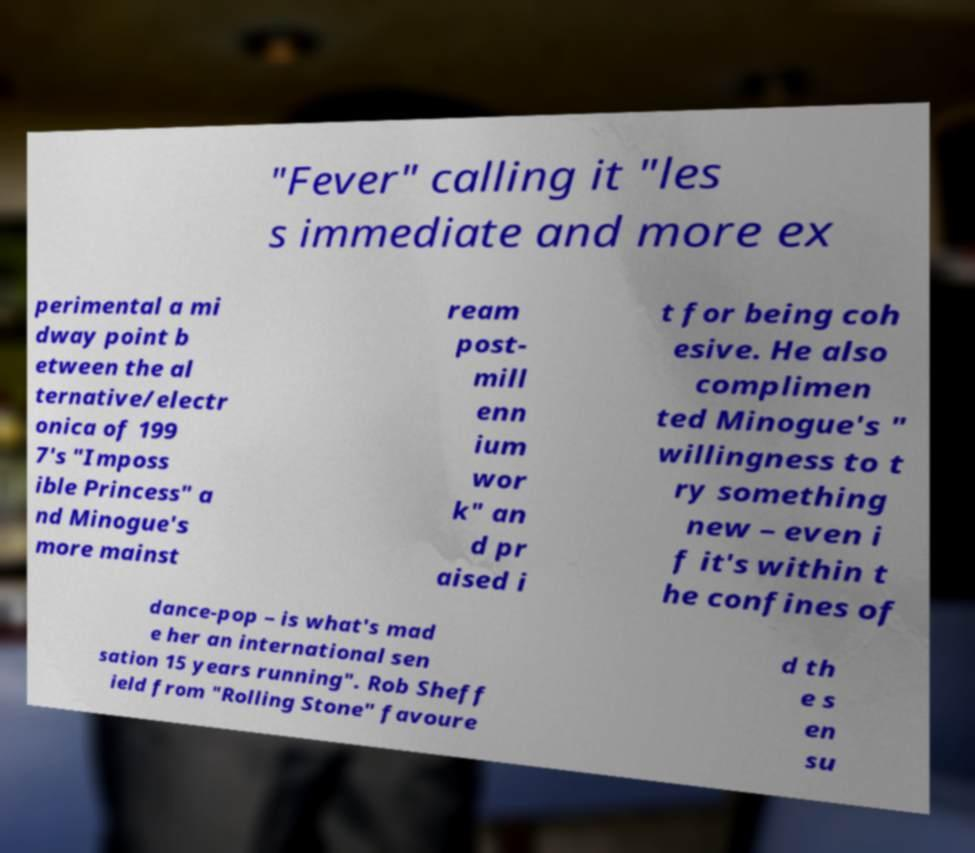Could you extract and type out the text from this image? "Fever" calling it "les s immediate and more ex perimental a mi dway point b etween the al ternative/electr onica of 199 7's "Imposs ible Princess" a nd Minogue's more mainst ream post- mill enn ium wor k" an d pr aised i t for being coh esive. He also complimen ted Minogue's " willingness to t ry something new – even i f it's within t he confines of dance-pop – is what's mad e her an international sen sation 15 years running". Rob Sheff ield from "Rolling Stone" favoure d th e s en su 